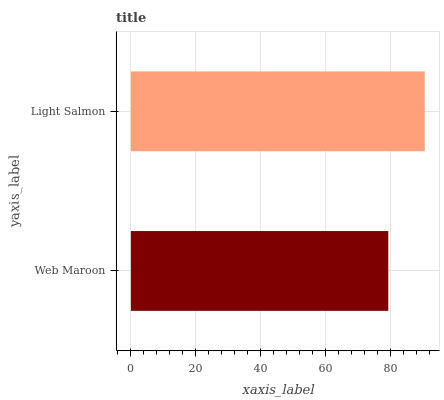Is Web Maroon the minimum?
Answer yes or no. Yes. Is Light Salmon the maximum?
Answer yes or no. Yes. Is Light Salmon the minimum?
Answer yes or no. No. Is Light Salmon greater than Web Maroon?
Answer yes or no. Yes. Is Web Maroon less than Light Salmon?
Answer yes or no. Yes. Is Web Maroon greater than Light Salmon?
Answer yes or no. No. Is Light Salmon less than Web Maroon?
Answer yes or no. No. Is Light Salmon the high median?
Answer yes or no. Yes. Is Web Maroon the low median?
Answer yes or no. Yes. Is Web Maroon the high median?
Answer yes or no. No. Is Light Salmon the low median?
Answer yes or no. No. 